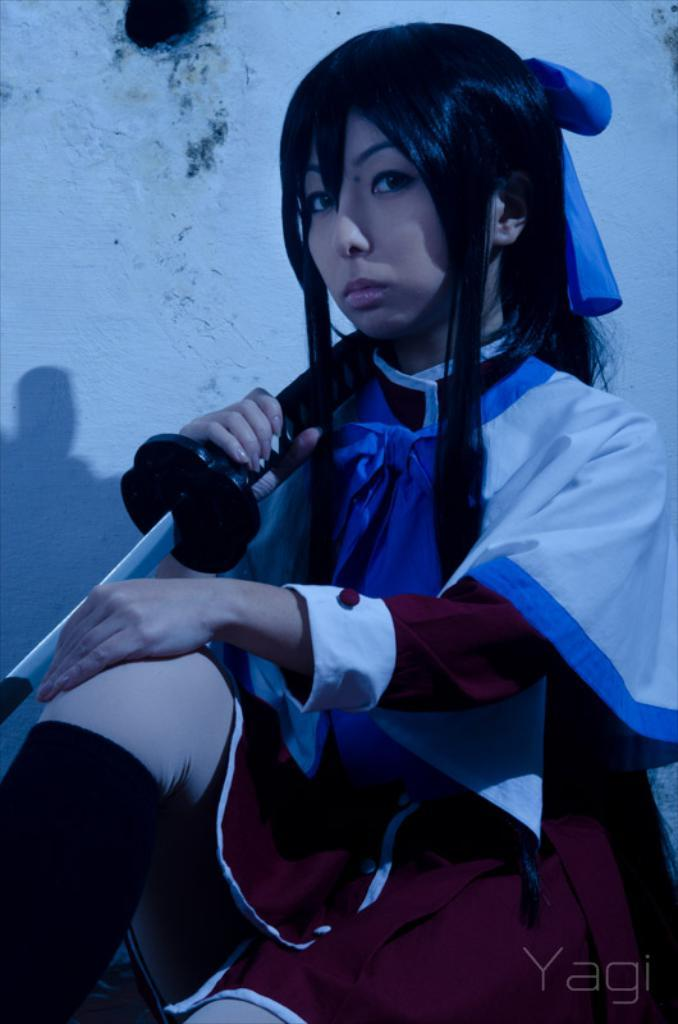Who is the main subject in the picture? There is a woman in the picture. What is the woman doing in the image? The woman is sitting. What is the woman wearing in the image? The woman is wearing a dress. What object is the woman holding in the image? The woman is holding a sword. What can be seen in the background of the picture? There is a wall in the background of the picture. What caption is written below the image? There is no caption present in the image. Is there a boy visible in the image? No, there is no boy present in the image; it features a woman holding a sword. 